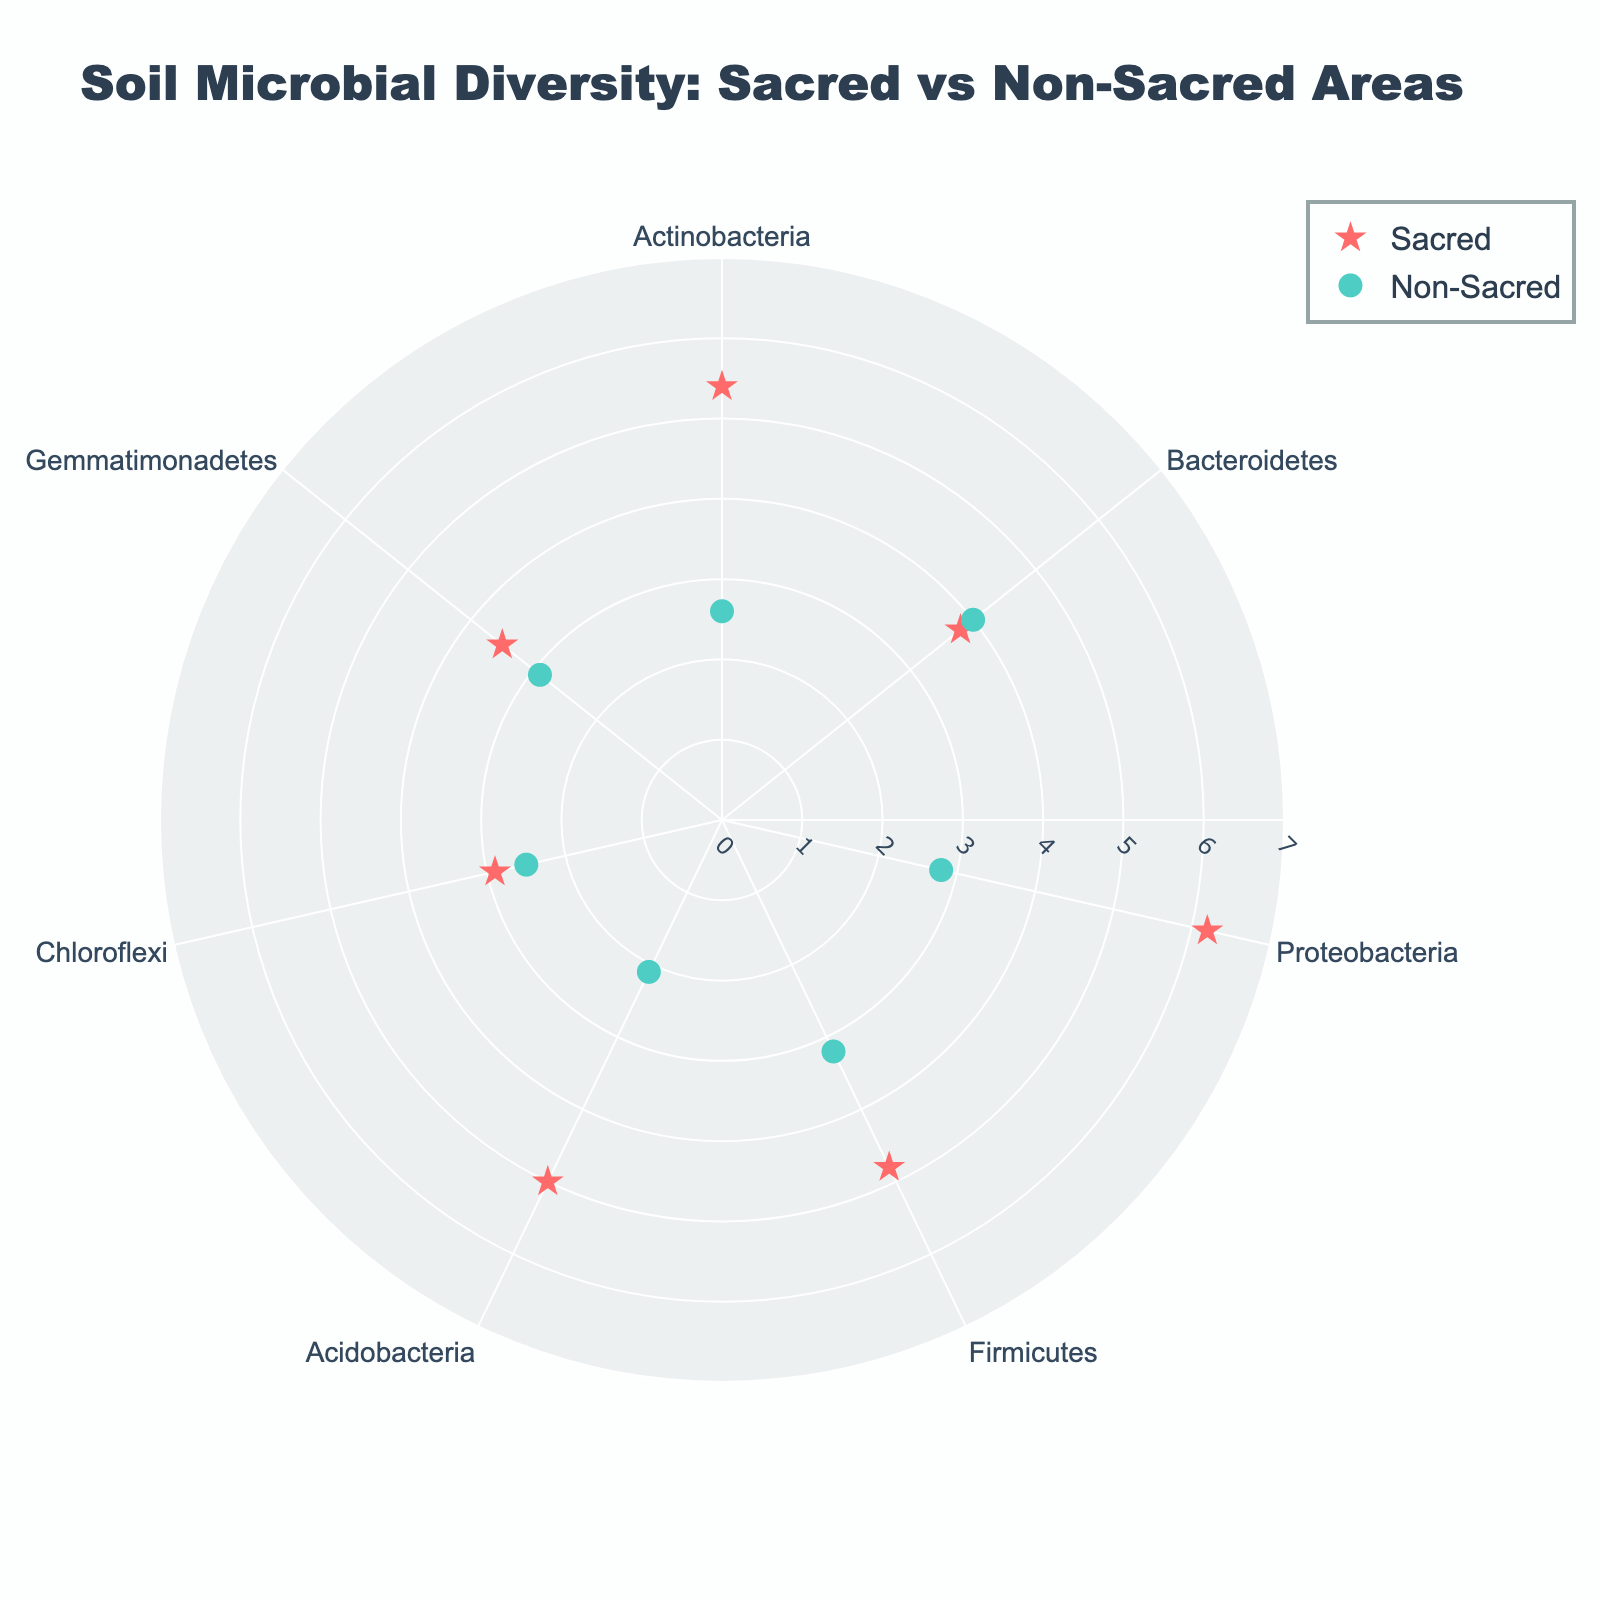Which area type has a higher count for Actinobacteria? Examine the markers for Actinobacteria species on the chart. There are two Actinobacteria markers: one for Sacred (radius 5.4) and one for Non-Sacred (radius 2.6). Sacred has a higher radius.
Answer: Sacred How does the abundance of Proteobacteria differ between sacred and non-sacred areas? Look at the markers for Proteobacteria in both areas: Sacred has a radius of 6.2, while Non-Sacred has a radius of 2.8. The difference is 6.2 - 2.8 = 3.4.
Answer: 3.4 What's the average radius of Bacteroidetes for both areas? For Sacred, radius is 3.8, and for Non-Sacred, radius is 4.0. The average is (3.8 + 4.0) / 2 = 3.9.
Answer: 3.9 Which species has the smallest difference in microbial diversity between sacred and non-sacred areas? Calculate the differences: Actinobacteria (5.4 - 2.6 = 2.8), Bacteroidetes (4.0 - 3.8 = 0.2), Proteobacteria (6.2 - 2.8 = 3.4), Firmicutes (4.8 - 3.2 = 1.6), Acidobacteria (5.0 - 2.1 = 2.9), Chloroflexi (2.9 - 2.5 = 0.4), Gemmatimonadetes (3.5 - 2.9 = 0.6). The smallest difference is 0.2 for Bacteroidetes.
Answer: Bacteroidetes What is the overall trend in microbial diversity between sacred and non-sacred areas? Compare the radii of all species markers in both areas. Sacred areas generally have higher radii (abundance) compared to Non-Sacred areas.
Answer: Sacred areas have higher microbial diversity How many different species are shown in the figure? Count the unique species names listed along the theta axis. The species include Actinobacteria, Bacteroidetes, Proteobacteria, Firmicutes, Acidobacteria, Chloroflexi, and Gemmatimonadetes.
Answer: 7 Which species has the highest abundance in any area, and in which area? Look for the species with the highest radius. Proteobacteria in the Sacred area has a radius of 6.2, which is the highest.
Answer: Proteobacteria in Sacred Compare the radii of Firmicutes between sacred and non-sacred areas. Sacred area for Firmicutes has a radius of 4.8, while Non-Sacred has 3.2. The difference is 4.8 - 3.2 = 1.6.
Answer: 1.6 What is the radius range for Chloroflexi across both areas? Sacred Chloroflexi has a radius of 2.9, and Non-Sacred has 2.5. The range is from 2.5 to 2.9.
Answer: 2.5 to 2.9 Which species in the non-sacred area has the smallest radius? Compare the radii of species in the non-sacred area: Actinobacteria (2.6), Bacteroidetes (4.0), Proteobacteria (2.8), Firmicutes (3.2), Acidobacteria (2.1), Chloroflexi (2.5), and Gemmatimonadetes (2.9). The smallest is Acidobacteria with a radius of 2.1.
Answer: Acidobacteria 